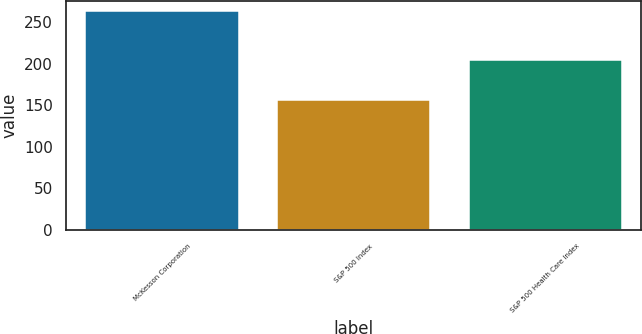<chart> <loc_0><loc_0><loc_500><loc_500><bar_chart><fcel>McKesson Corporation<fcel>S&P 500 Index<fcel>S&P 500 Health Care Index<nl><fcel>262.91<fcel>156.55<fcel>204.17<nl></chart> 